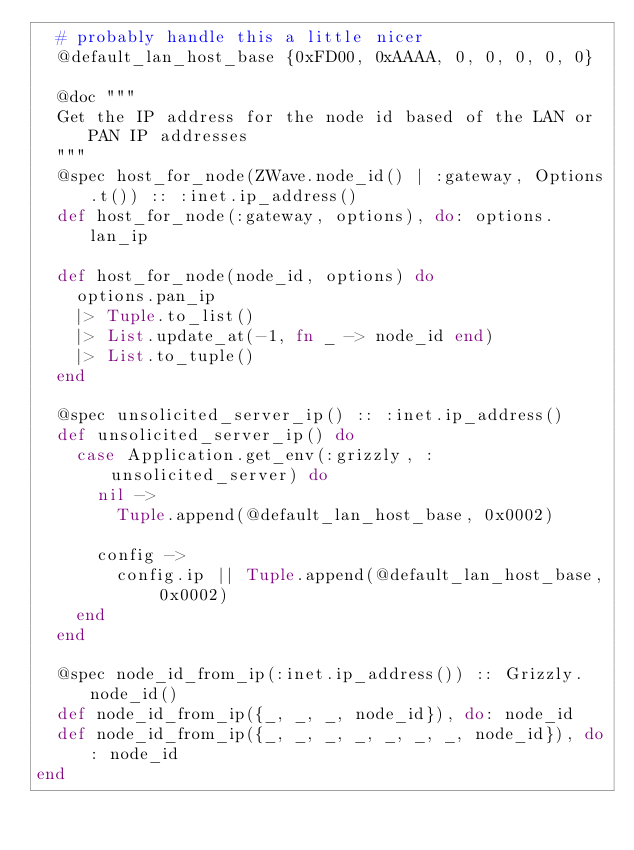Convert code to text. <code><loc_0><loc_0><loc_500><loc_500><_Elixir_>  # probably handle this a little nicer
  @default_lan_host_base {0xFD00, 0xAAAA, 0, 0, 0, 0, 0}

  @doc """
  Get the IP address for the node id based of the LAN or PAN IP addresses
  """
  @spec host_for_node(ZWave.node_id() | :gateway, Options.t()) :: :inet.ip_address()
  def host_for_node(:gateway, options), do: options.lan_ip

  def host_for_node(node_id, options) do
    options.pan_ip
    |> Tuple.to_list()
    |> List.update_at(-1, fn _ -> node_id end)
    |> List.to_tuple()
  end

  @spec unsolicited_server_ip() :: :inet.ip_address()
  def unsolicited_server_ip() do
    case Application.get_env(:grizzly, :unsolicited_server) do
      nil ->
        Tuple.append(@default_lan_host_base, 0x0002)

      config ->
        config.ip || Tuple.append(@default_lan_host_base, 0x0002)
    end
  end

  @spec node_id_from_ip(:inet.ip_address()) :: Grizzly.node_id()
  def node_id_from_ip({_, _, _, node_id}), do: node_id
  def node_id_from_ip({_, _, _, _, _, _, _, node_id}), do: node_id
end
</code> 